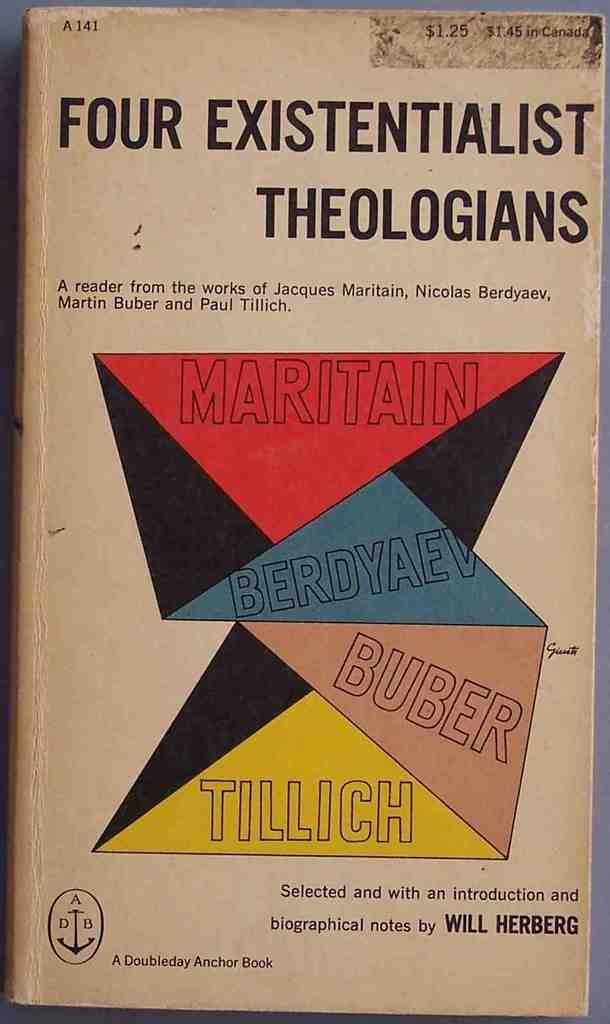<image>
Offer a succinct explanation of the picture presented. An old brown textbook titled Four Existentialist Theologians. 